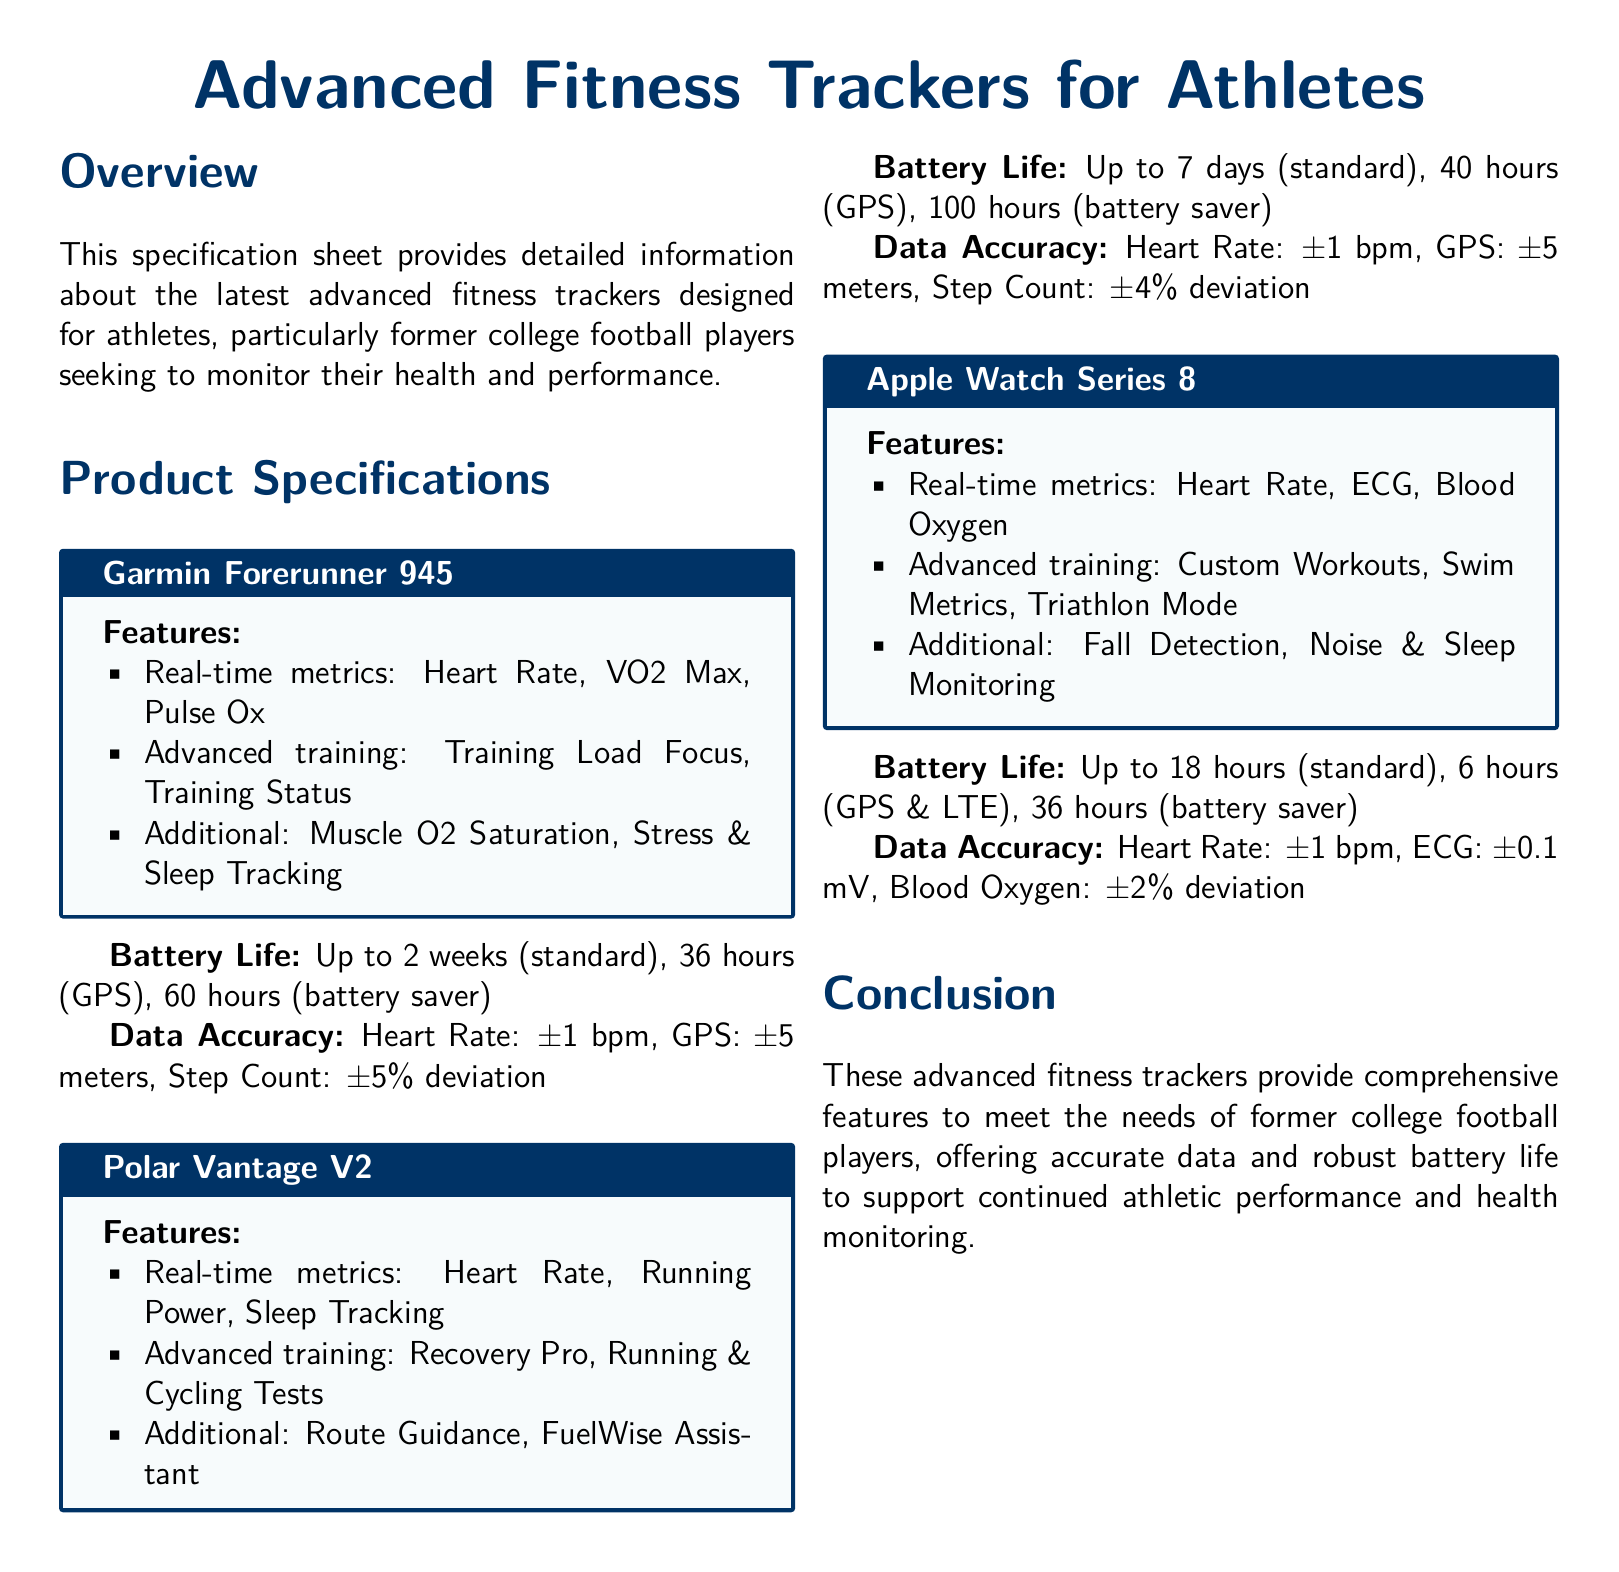What are the advanced features of the Garmin Forerunner 945? The Garmin Forerunner 945 features Heart Rate, VO2 Max, Pulse Ox, Training Load Focus, Training Status, and Muscle O2 Saturation, Stress & Sleep Tracking.
Answer: Heart Rate, VO2 Max, Pulse Ox What is the battery life of the Polar Vantage V2 in GPS mode? The battery life of the Polar Vantage V2 in GPS mode is provided in the specifications section.
Answer: 40 hours What is the data accuracy for heart rate measurement in the Apple Watch Series 8? The document specifies the accuracy range for heart rate in the Apple Watch Series 8.
Answer: ±1 bpm Which fitness tracker offers Recovery Pro? The specific features of each tracker are listed, and Recovery Pro is mentioned under one of them.
Answer: Polar Vantage V2 How long does the Garmin Forerunner 945 last on battery saver mode? The document states the battery life in battery saver mode for the Garmin Forerunner 945.
Answer: 60 hours What is the total deviation percentage for step count accuracy in the Polar Vantage V2? The step count accuracy deviation for the Polar Vantage V2 is listed in the data accuracy section.
Answer: ±4% What health metrics can the Apple Watch Series 8 monitor? The document specifically lists the health metrics monitored by the Apple Watch Series 8.
Answer: Heart Rate, ECG, Blood Oxygen Is the conclusion section present in the document? The conclusion summarizes the features that meet the needs of the target audience stated earlier in the document.
Answer: Yes 